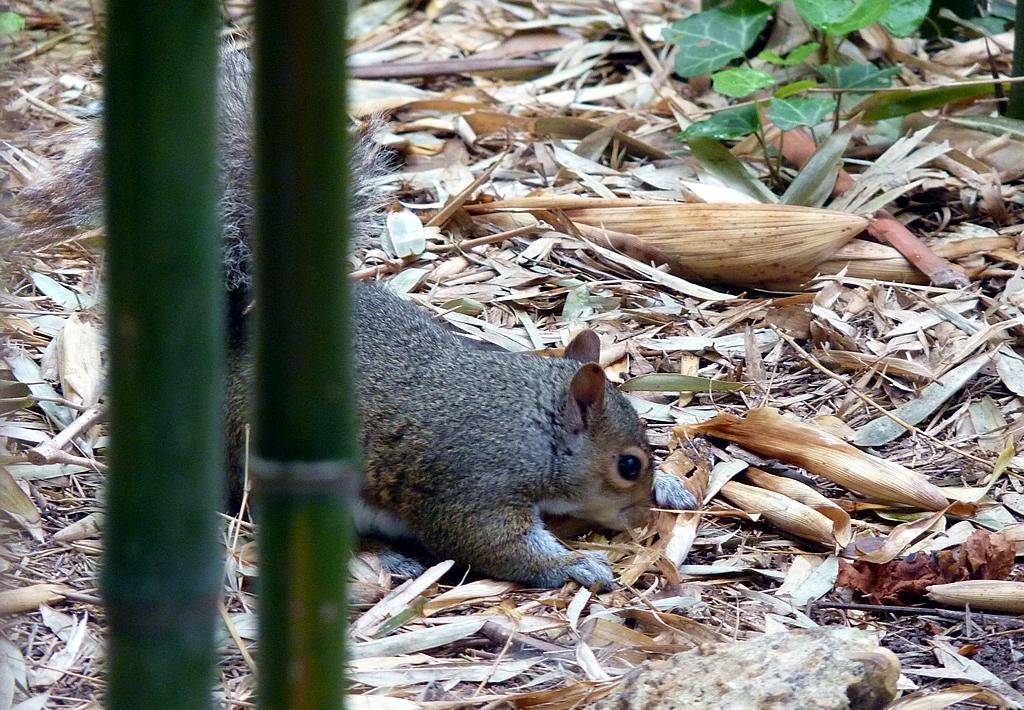Can you describe this image briefly? In the image there is a squirrel standing on the land covered with dry straws. 